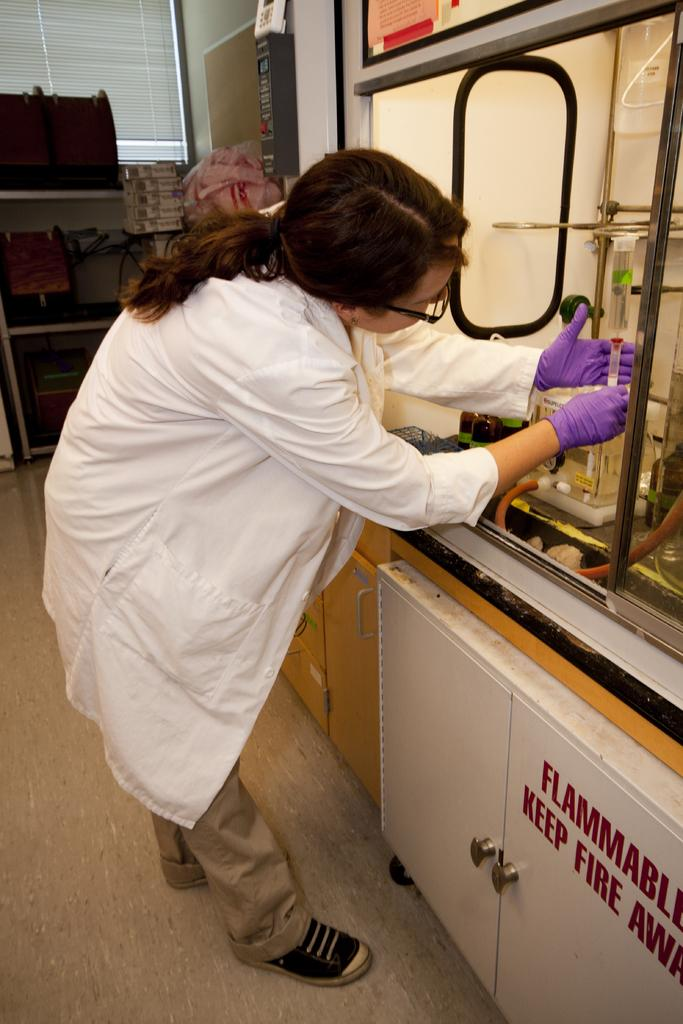<image>
Share a concise interpretation of the image provided. A woman with glasses and a white lab coat handles a sample with purple gloves above a cabinet that says "Flammable." 